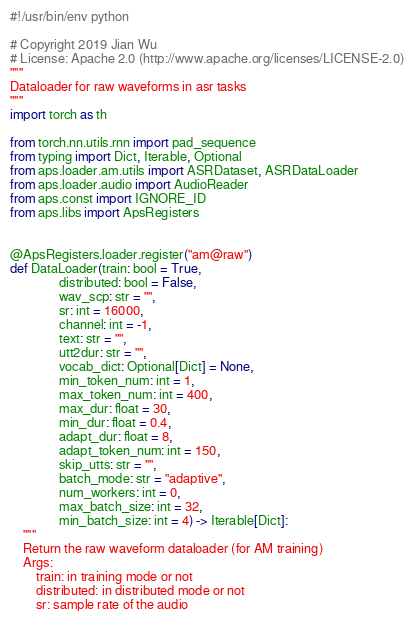<code> <loc_0><loc_0><loc_500><loc_500><_Python_>#!/usr/bin/env python

# Copyright 2019 Jian Wu
# License: Apache 2.0 (http://www.apache.org/licenses/LICENSE-2.0)
"""
Dataloader for raw waveforms in asr tasks
"""
import torch as th

from torch.nn.utils.rnn import pad_sequence
from typing import Dict, Iterable, Optional
from aps.loader.am.utils import ASRDataset, ASRDataLoader
from aps.loader.audio import AudioReader
from aps.const import IGNORE_ID
from aps.libs import ApsRegisters


@ApsRegisters.loader.register("am@raw")
def DataLoader(train: bool = True,
               distributed: bool = False,
               wav_scp: str = "",
               sr: int = 16000,
               channel: int = -1,
               text: str = "",
               utt2dur: str = "",
               vocab_dict: Optional[Dict] = None,
               min_token_num: int = 1,
               max_token_num: int = 400,
               max_dur: float = 30,
               min_dur: float = 0.4,
               adapt_dur: float = 8,
               adapt_token_num: int = 150,
               skip_utts: str = "",
               batch_mode: str = "adaptive",
               num_workers: int = 0,
               max_batch_size: int = 32,
               min_batch_size: int = 4) -> Iterable[Dict]:
    """
    Return the raw waveform dataloader (for AM training)
    Args:
        train: in training mode or not
        distributed: in distributed mode or not
        sr: sample rate of the audio</code> 